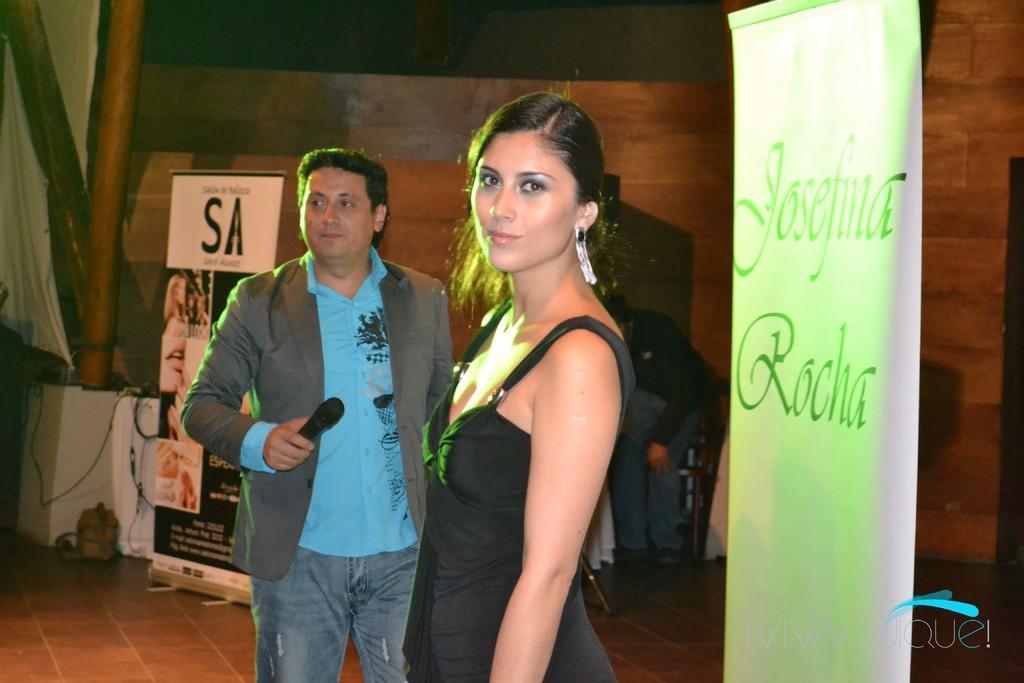Please provide a concise description of this image. In this picture we can see there are three persons standing on the floor. A man is holding a microphone. On the right side of the woman there is a banner. Behind the two persons, there is another banner, cables, wall and some objects. On the image there is a watermark. 